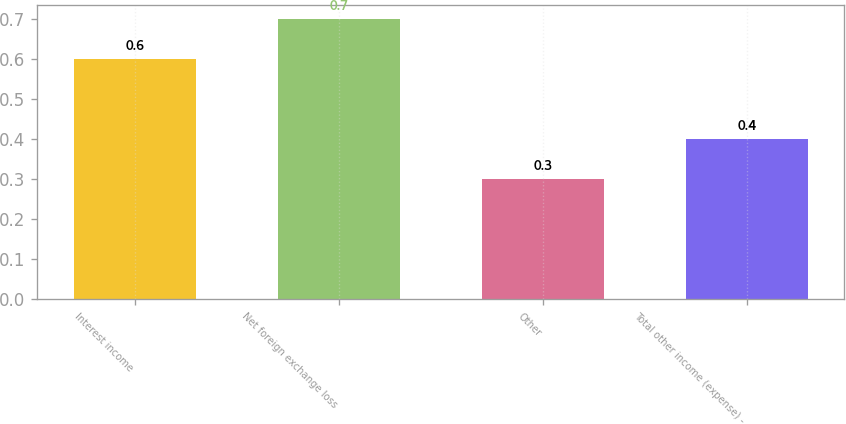Convert chart to OTSL. <chart><loc_0><loc_0><loc_500><loc_500><bar_chart><fcel>Interest income<fcel>Net foreign exchange loss<fcel>Other<fcel>Total other income (expense) -<nl><fcel>0.6<fcel>0.7<fcel>0.3<fcel>0.4<nl></chart> 